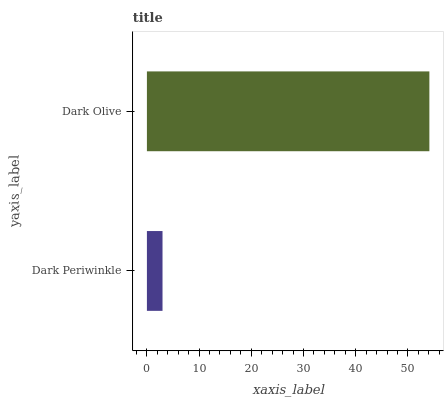Is Dark Periwinkle the minimum?
Answer yes or no. Yes. Is Dark Olive the maximum?
Answer yes or no. Yes. Is Dark Olive the minimum?
Answer yes or no. No. Is Dark Olive greater than Dark Periwinkle?
Answer yes or no. Yes. Is Dark Periwinkle less than Dark Olive?
Answer yes or no. Yes. Is Dark Periwinkle greater than Dark Olive?
Answer yes or no. No. Is Dark Olive less than Dark Periwinkle?
Answer yes or no. No. Is Dark Olive the high median?
Answer yes or no. Yes. Is Dark Periwinkle the low median?
Answer yes or no. Yes. Is Dark Periwinkle the high median?
Answer yes or no. No. Is Dark Olive the low median?
Answer yes or no. No. 